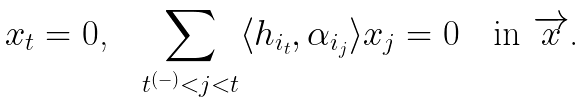<formula> <loc_0><loc_0><loc_500><loc_500>\text {$x_{t}=0$,\quad $\sum_{t^{(-)}<j<t}\langle h_{i_{t}}, \alpha_{i_{j}}\rangle x_{j}=0$\quad in $\overrightarrow{x}$.}</formula> 